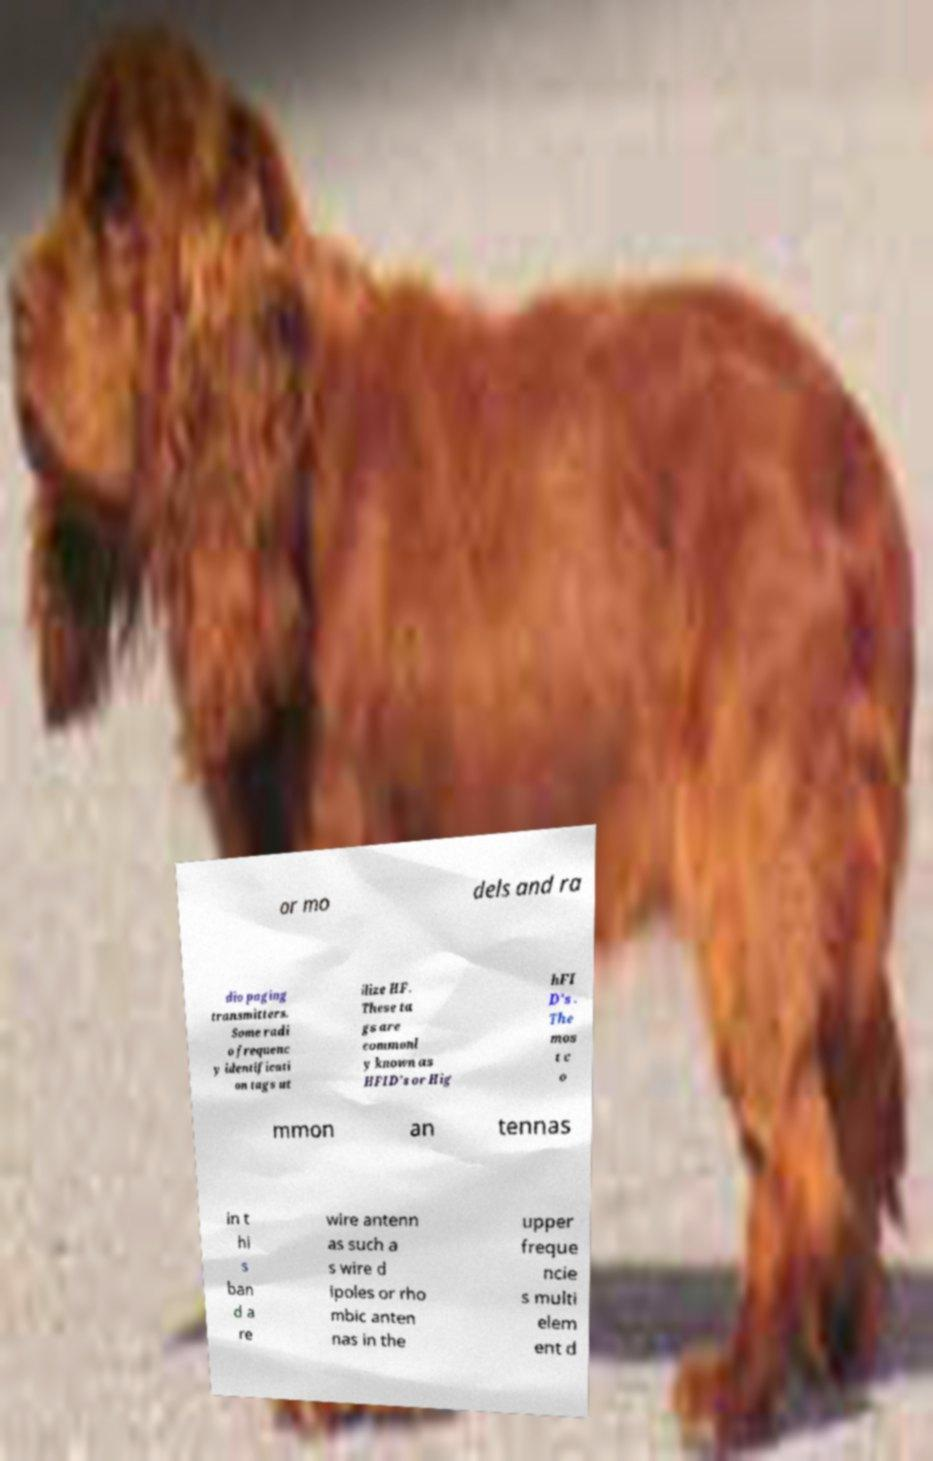Could you assist in decoding the text presented in this image and type it out clearly? or mo dels and ra dio paging transmitters. Some radi o frequenc y identificati on tags ut ilize HF. These ta gs are commonl y known as HFID's or Hig hFI D's . The mos t c o mmon an tennas in t hi s ban d a re wire antenn as such a s wire d ipoles or rho mbic anten nas in the upper freque ncie s multi elem ent d 